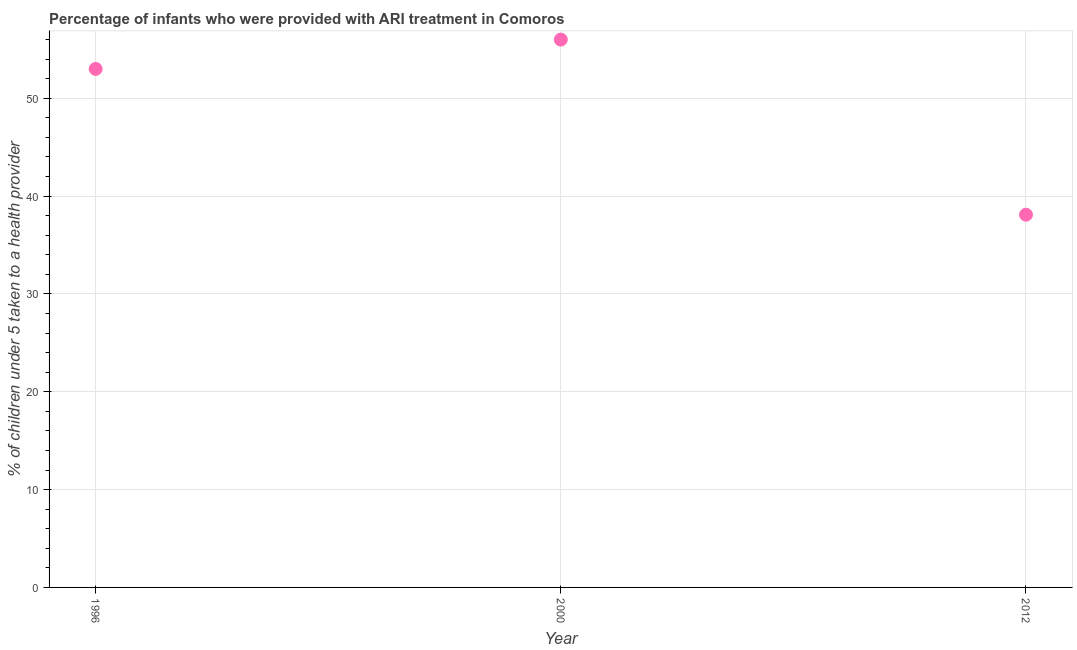What is the percentage of children who were provided with ari treatment in 2012?
Offer a very short reply. 38.1. Across all years, what is the maximum percentage of children who were provided with ari treatment?
Your answer should be compact. 56. Across all years, what is the minimum percentage of children who were provided with ari treatment?
Offer a terse response. 38.1. What is the sum of the percentage of children who were provided with ari treatment?
Ensure brevity in your answer.  147.1. What is the difference between the percentage of children who were provided with ari treatment in 1996 and 2012?
Offer a very short reply. 14.9. What is the average percentage of children who were provided with ari treatment per year?
Provide a short and direct response. 49.03. Do a majority of the years between 2012 and 1996 (inclusive) have percentage of children who were provided with ari treatment greater than 46 %?
Provide a succinct answer. No. What is the ratio of the percentage of children who were provided with ari treatment in 1996 to that in 2012?
Keep it short and to the point. 1.39. Is the percentage of children who were provided with ari treatment in 1996 less than that in 2012?
Your answer should be compact. No. What is the difference between the highest and the second highest percentage of children who were provided with ari treatment?
Your answer should be very brief. 3. What is the difference between the highest and the lowest percentage of children who were provided with ari treatment?
Offer a very short reply. 17.9. In how many years, is the percentage of children who were provided with ari treatment greater than the average percentage of children who were provided with ari treatment taken over all years?
Ensure brevity in your answer.  2. How many years are there in the graph?
Provide a short and direct response. 3. What is the title of the graph?
Your response must be concise. Percentage of infants who were provided with ARI treatment in Comoros. What is the label or title of the X-axis?
Keep it short and to the point. Year. What is the label or title of the Y-axis?
Offer a terse response. % of children under 5 taken to a health provider. What is the % of children under 5 taken to a health provider in 2000?
Offer a very short reply. 56. What is the % of children under 5 taken to a health provider in 2012?
Offer a terse response. 38.1. What is the difference between the % of children under 5 taken to a health provider in 1996 and 2012?
Offer a very short reply. 14.9. What is the ratio of the % of children under 5 taken to a health provider in 1996 to that in 2000?
Provide a short and direct response. 0.95. What is the ratio of the % of children under 5 taken to a health provider in 1996 to that in 2012?
Ensure brevity in your answer.  1.39. What is the ratio of the % of children under 5 taken to a health provider in 2000 to that in 2012?
Give a very brief answer. 1.47. 